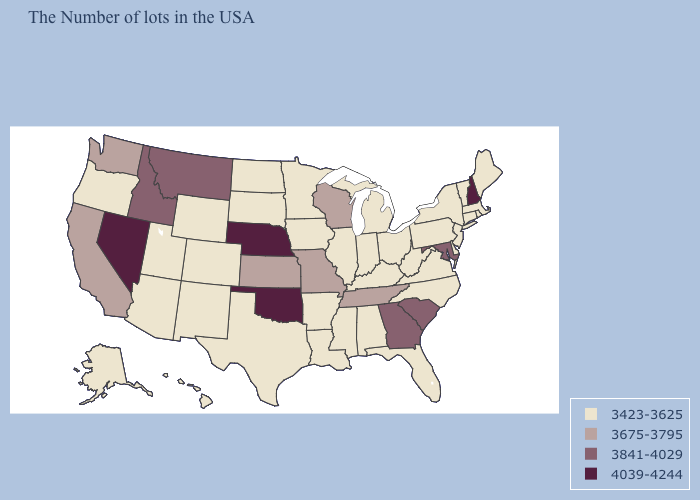What is the value of Kansas?
Give a very brief answer. 3675-3795. What is the lowest value in the West?
Answer briefly. 3423-3625. What is the value of Illinois?
Answer briefly. 3423-3625. What is the value of Indiana?
Keep it brief. 3423-3625. Name the states that have a value in the range 3423-3625?
Keep it brief. Maine, Massachusetts, Rhode Island, Vermont, Connecticut, New York, New Jersey, Delaware, Pennsylvania, Virginia, North Carolina, West Virginia, Ohio, Florida, Michigan, Kentucky, Indiana, Alabama, Illinois, Mississippi, Louisiana, Arkansas, Minnesota, Iowa, Texas, South Dakota, North Dakota, Wyoming, Colorado, New Mexico, Utah, Arizona, Oregon, Alaska, Hawaii. Does Mississippi have the same value as Wyoming?
Write a very short answer. Yes. Which states hav the highest value in the South?
Concise answer only. Oklahoma. What is the highest value in the South ?
Keep it brief. 4039-4244. Name the states that have a value in the range 3423-3625?
Write a very short answer. Maine, Massachusetts, Rhode Island, Vermont, Connecticut, New York, New Jersey, Delaware, Pennsylvania, Virginia, North Carolina, West Virginia, Ohio, Florida, Michigan, Kentucky, Indiana, Alabama, Illinois, Mississippi, Louisiana, Arkansas, Minnesota, Iowa, Texas, South Dakota, North Dakota, Wyoming, Colorado, New Mexico, Utah, Arizona, Oregon, Alaska, Hawaii. What is the highest value in states that border Idaho?
Short answer required. 4039-4244. Name the states that have a value in the range 3841-4029?
Quick response, please. Maryland, South Carolina, Georgia, Montana, Idaho. Among the states that border Nebraska , which have the highest value?
Give a very brief answer. Missouri, Kansas. What is the value of California?
Answer briefly. 3675-3795. What is the lowest value in the MidWest?
Quick response, please. 3423-3625. Does Kentucky have the highest value in the USA?
Quick response, please. No. 